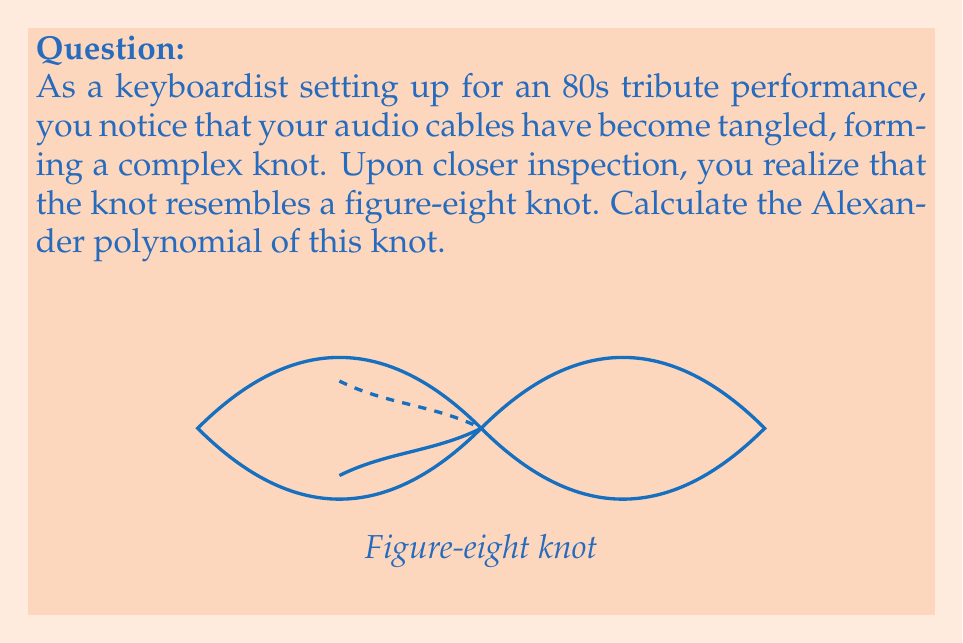What is the answer to this math problem? To calculate the Alexander polynomial of the figure-eight knot, we'll follow these steps:

1) First, we need to create a knot diagram and label the arcs and crossings. The figure-eight knot has 4 crossings.

2) Next, we construct the Alexander matrix. For a knot with n crossings, this is an (n-1) × n matrix. In our case, it's a 3 × 4 matrix.

3) The matrix entries are determined by the following rules:
   - For each crossing, we get a row in the matrix.
   - The columns correspond to the arcs of the knot.
   - At each crossing, we assign +1, -1, or (1-t) to the appropriate columns based on the orientation of the crossing.

4) For the figure-eight knot, the Alexander matrix looks like this:

   $$
   \begin{pmatrix}
   1-t & -1 & 1 & 0 \\
   -1 & 1-t & 0 & 1 \\
   t & 0 & -t & 1-t
   \end{pmatrix}
   $$

5) To find the Alexander polynomial, we calculate the determinant of any 3 × 3 minor of this matrix and divide by $(t-1)$.

6) Let's choose to delete the last column. The determinant is:

   $$\det \begin{pmatrix}
   1-t & -1 & 1 \\
   -1 & 1-t & 0 \\
   t & 0 & -t
   \end{pmatrix} = -t^2 + 3t - 1$$

7) Dividing by $(t-1)$, we get:

   $$\frac{-t^2 + 3t - 1}{t-1} = -t + 1 - \frac{1}{t-1} = -t + 2 - \frac{1}{t}$$

8) The Alexander polynomial is typically normalized so that the lowest degree term has a positive coefficient. In this case, we multiply by -1:

   $$\Delta(t) = t - 2 + \frac{1}{t} = t - 2 + t^{-1}$$

This is the Alexander polynomial of the figure-eight knot.
Answer: $t - 2 + t^{-1}$ 